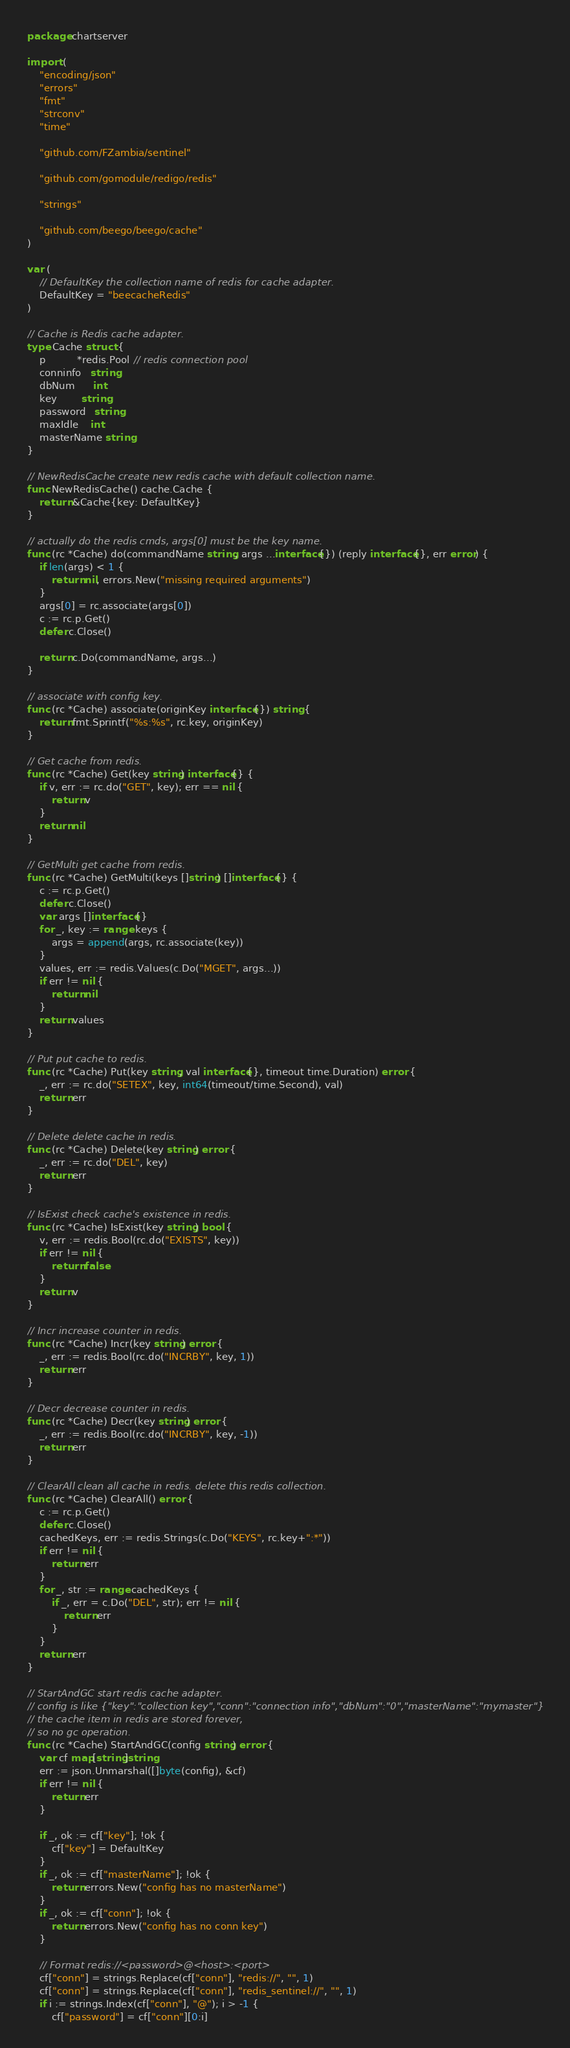Convert code to text. <code><loc_0><loc_0><loc_500><loc_500><_Go_>package chartserver

import (
	"encoding/json"
	"errors"
	"fmt"
	"strconv"
	"time"

	"github.com/FZambia/sentinel"

	"github.com/gomodule/redigo/redis"

	"strings"

	"github.com/beego/beego/cache"
)

var (
	// DefaultKey the collection name of redis for cache adapter.
	DefaultKey = "beecacheRedis"
)

// Cache is Redis cache adapter.
type Cache struct {
	p          *redis.Pool // redis connection pool
	conninfo   string
	dbNum      int
	key        string
	password   string
	maxIdle    int
	masterName string
}

// NewRedisCache create new redis cache with default collection name.
func NewRedisCache() cache.Cache {
	return &Cache{key: DefaultKey}
}

// actually do the redis cmds, args[0] must be the key name.
func (rc *Cache) do(commandName string, args ...interface{}) (reply interface{}, err error) {
	if len(args) < 1 {
		return nil, errors.New("missing required arguments")
	}
	args[0] = rc.associate(args[0])
	c := rc.p.Get()
	defer c.Close()

	return c.Do(commandName, args...)
}

// associate with config key.
func (rc *Cache) associate(originKey interface{}) string {
	return fmt.Sprintf("%s:%s", rc.key, originKey)
}

// Get cache from redis.
func (rc *Cache) Get(key string) interface{} {
	if v, err := rc.do("GET", key); err == nil {
		return v
	}
	return nil
}

// GetMulti get cache from redis.
func (rc *Cache) GetMulti(keys []string) []interface{} {
	c := rc.p.Get()
	defer c.Close()
	var args []interface{}
	for _, key := range keys {
		args = append(args, rc.associate(key))
	}
	values, err := redis.Values(c.Do("MGET", args...))
	if err != nil {
		return nil
	}
	return values
}

// Put put cache to redis.
func (rc *Cache) Put(key string, val interface{}, timeout time.Duration) error {
	_, err := rc.do("SETEX", key, int64(timeout/time.Second), val)
	return err
}

// Delete delete cache in redis.
func (rc *Cache) Delete(key string) error {
	_, err := rc.do("DEL", key)
	return err
}

// IsExist check cache's existence in redis.
func (rc *Cache) IsExist(key string) bool {
	v, err := redis.Bool(rc.do("EXISTS", key))
	if err != nil {
		return false
	}
	return v
}

// Incr increase counter in redis.
func (rc *Cache) Incr(key string) error {
	_, err := redis.Bool(rc.do("INCRBY", key, 1))
	return err
}

// Decr decrease counter in redis.
func (rc *Cache) Decr(key string) error {
	_, err := redis.Bool(rc.do("INCRBY", key, -1))
	return err
}

// ClearAll clean all cache in redis. delete this redis collection.
func (rc *Cache) ClearAll() error {
	c := rc.p.Get()
	defer c.Close()
	cachedKeys, err := redis.Strings(c.Do("KEYS", rc.key+":*"))
	if err != nil {
		return err
	}
	for _, str := range cachedKeys {
		if _, err = c.Do("DEL", str); err != nil {
			return err
		}
	}
	return err
}

// StartAndGC start redis cache adapter.
// config is like {"key":"collection key","conn":"connection info","dbNum":"0","masterName":"mymaster"}
// the cache item in redis are stored forever,
// so no gc operation.
func (rc *Cache) StartAndGC(config string) error {
	var cf map[string]string
	err := json.Unmarshal([]byte(config), &cf)
	if err != nil {
		return err
	}

	if _, ok := cf["key"]; !ok {
		cf["key"] = DefaultKey
	}
	if _, ok := cf["masterName"]; !ok {
		return errors.New("config has no masterName")
	}
	if _, ok := cf["conn"]; !ok {
		return errors.New("config has no conn key")
	}

	// Format redis://<password>@<host>:<port>
	cf["conn"] = strings.Replace(cf["conn"], "redis://", "", 1)
	cf["conn"] = strings.Replace(cf["conn"], "redis_sentinel://", "", 1)
	if i := strings.Index(cf["conn"], "@"); i > -1 {
		cf["password"] = cf["conn"][0:i]</code> 